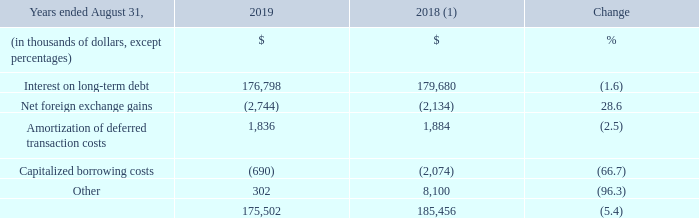3.4 FINANCIAL EXPENSE
(1) Fiscal 2018 was restated to reclassify results from Cogeco Peer 1 as discontinued operations. For further details, please consult the "Discontinued operations" section.
Fiscal 2019 financial expense decreased by 5.4% mainly due to:
• the reimbursement at maturity of the Senior Secured Notes Series B on October 1, 2018; • the reimbursements of $65 million and US$35 million under the Canadian Revolving Facility during the second quarter of fiscal 2019 and of US$328 million during the third quarter of fiscal 2019 following the sale of Cogeco Peer 1; and
• early reimbursement of the US$400 million Senior Unsecured Notes during the third quarter of fiscal 2018 which resulted in a $6.2 million redemption premium and the write-off of the unamortized deferred transaction costs of $2.5 million; partly offset by • higher interest cost on the First Lien Credit Facilities resulting from the full year impact of the financing of the MetroCast acquisition; and • the appreciation of the US dollar against the Canadian dollar compared to the prior year.
What was the reimbursement amount under the Canadian Revolving Facility during the second quarter of 2019? $65 million and us$35 million. What was the early reimbursement amount of Senior Unsecured Notes in the third quarter of 2018? Us$400 million. What was the redemption premium in third quarter of 2018? $6.2 million redemption premium. What was the increase / (decrease) in the interest on long-term debt from 2018 to 2019?
Answer scale should be: thousand. 176,798 - 179,680
Answer: -2882. What was the average net foreign exchange gains between 2018 and 2019?
Answer scale should be: thousand. - (2,744 + 2,134) / 2
Answer: -2439. What was the increase / (decrease) in the amortization of deferred transactions costs from 2018 to 2019?
Answer scale should be: thousand. 1,836 - 1,884
Answer: -48. 